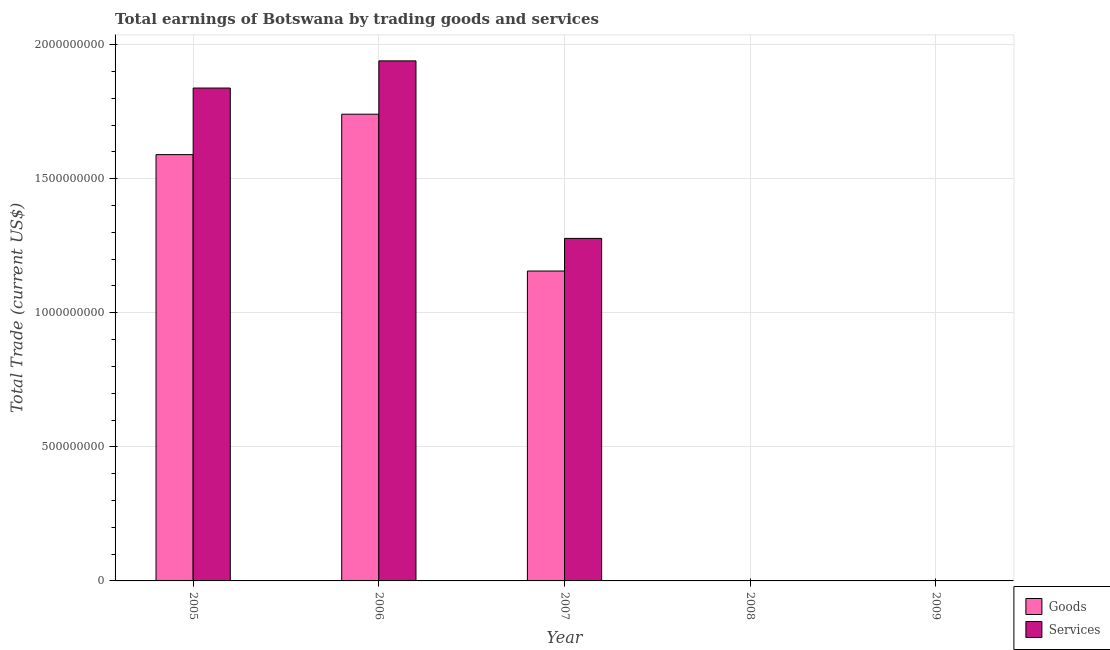Are the number of bars on each tick of the X-axis equal?
Your response must be concise. No. In how many cases, is the number of bars for a given year not equal to the number of legend labels?
Provide a short and direct response. 2. What is the amount earned by trading services in 2006?
Ensure brevity in your answer.  1.94e+09. Across all years, what is the maximum amount earned by trading services?
Keep it short and to the point. 1.94e+09. In which year was the amount earned by trading services maximum?
Offer a terse response. 2006. What is the total amount earned by trading services in the graph?
Make the answer very short. 5.05e+09. What is the difference between the amount earned by trading services in 2006 and that in 2007?
Offer a very short reply. 6.62e+08. What is the difference between the amount earned by trading services in 2006 and the amount earned by trading goods in 2008?
Provide a short and direct response. 1.94e+09. What is the average amount earned by trading goods per year?
Offer a very short reply. 8.97e+08. In the year 2007, what is the difference between the amount earned by trading services and amount earned by trading goods?
Your answer should be compact. 0. What is the ratio of the amount earned by trading services in 2005 to that in 2007?
Your answer should be compact. 1.44. What is the difference between the highest and the second highest amount earned by trading goods?
Ensure brevity in your answer.  1.51e+08. What is the difference between the highest and the lowest amount earned by trading goods?
Your answer should be compact. 1.74e+09. Is the sum of the amount earned by trading services in 2005 and 2007 greater than the maximum amount earned by trading goods across all years?
Provide a short and direct response. Yes. Are all the bars in the graph horizontal?
Your answer should be very brief. No. Are the values on the major ticks of Y-axis written in scientific E-notation?
Your answer should be compact. No. How are the legend labels stacked?
Give a very brief answer. Vertical. What is the title of the graph?
Ensure brevity in your answer.  Total earnings of Botswana by trading goods and services. Does "Official creditors" appear as one of the legend labels in the graph?
Keep it short and to the point. No. What is the label or title of the X-axis?
Ensure brevity in your answer.  Year. What is the label or title of the Y-axis?
Ensure brevity in your answer.  Total Trade (current US$). What is the Total Trade (current US$) of Goods in 2005?
Ensure brevity in your answer.  1.59e+09. What is the Total Trade (current US$) in Services in 2005?
Provide a short and direct response. 1.84e+09. What is the Total Trade (current US$) of Goods in 2006?
Make the answer very short. 1.74e+09. What is the Total Trade (current US$) of Services in 2006?
Make the answer very short. 1.94e+09. What is the Total Trade (current US$) of Goods in 2007?
Provide a succinct answer. 1.16e+09. What is the Total Trade (current US$) in Services in 2007?
Your answer should be very brief. 1.28e+09. What is the Total Trade (current US$) of Goods in 2008?
Your answer should be very brief. 0. What is the Total Trade (current US$) of Services in 2008?
Offer a terse response. 0. Across all years, what is the maximum Total Trade (current US$) of Goods?
Your answer should be compact. 1.74e+09. Across all years, what is the maximum Total Trade (current US$) in Services?
Provide a short and direct response. 1.94e+09. Across all years, what is the minimum Total Trade (current US$) in Goods?
Make the answer very short. 0. Across all years, what is the minimum Total Trade (current US$) of Services?
Keep it short and to the point. 0. What is the total Total Trade (current US$) of Goods in the graph?
Make the answer very short. 4.49e+09. What is the total Total Trade (current US$) in Services in the graph?
Make the answer very short. 5.05e+09. What is the difference between the Total Trade (current US$) in Goods in 2005 and that in 2006?
Your answer should be compact. -1.51e+08. What is the difference between the Total Trade (current US$) in Services in 2005 and that in 2006?
Your response must be concise. -1.01e+08. What is the difference between the Total Trade (current US$) in Goods in 2005 and that in 2007?
Your answer should be very brief. 4.34e+08. What is the difference between the Total Trade (current US$) in Services in 2005 and that in 2007?
Keep it short and to the point. 5.61e+08. What is the difference between the Total Trade (current US$) of Goods in 2006 and that in 2007?
Give a very brief answer. 5.85e+08. What is the difference between the Total Trade (current US$) in Services in 2006 and that in 2007?
Make the answer very short. 6.62e+08. What is the difference between the Total Trade (current US$) of Goods in 2005 and the Total Trade (current US$) of Services in 2006?
Make the answer very short. -3.50e+08. What is the difference between the Total Trade (current US$) of Goods in 2005 and the Total Trade (current US$) of Services in 2007?
Your answer should be compact. 3.12e+08. What is the difference between the Total Trade (current US$) of Goods in 2006 and the Total Trade (current US$) of Services in 2007?
Your answer should be compact. 4.63e+08. What is the average Total Trade (current US$) in Goods per year?
Your answer should be compact. 8.97e+08. What is the average Total Trade (current US$) in Services per year?
Make the answer very short. 1.01e+09. In the year 2005, what is the difference between the Total Trade (current US$) in Goods and Total Trade (current US$) in Services?
Keep it short and to the point. -2.48e+08. In the year 2006, what is the difference between the Total Trade (current US$) in Goods and Total Trade (current US$) in Services?
Ensure brevity in your answer.  -1.99e+08. In the year 2007, what is the difference between the Total Trade (current US$) of Goods and Total Trade (current US$) of Services?
Offer a terse response. -1.22e+08. What is the ratio of the Total Trade (current US$) in Goods in 2005 to that in 2006?
Offer a terse response. 0.91. What is the ratio of the Total Trade (current US$) in Services in 2005 to that in 2006?
Keep it short and to the point. 0.95. What is the ratio of the Total Trade (current US$) of Goods in 2005 to that in 2007?
Your answer should be very brief. 1.38. What is the ratio of the Total Trade (current US$) of Services in 2005 to that in 2007?
Keep it short and to the point. 1.44. What is the ratio of the Total Trade (current US$) of Goods in 2006 to that in 2007?
Ensure brevity in your answer.  1.51. What is the ratio of the Total Trade (current US$) of Services in 2006 to that in 2007?
Your response must be concise. 1.52. What is the difference between the highest and the second highest Total Trade (current US$) in Goods?
Keep it short and to the point. 1.51e+08. What is the difference between the highest and the second highest Total Trade (current US$) in Services?
Your answer should be very brief. 1.01e+08. What is the difference between the highest and the lowest Total Trade (current US$) of Goods?
Give a very brief answer. 1.74e+09. What is the difference between the highest and the lowest Total Trade (current US$) of Services?
Keep it short and to the point. 1.94e+09. 